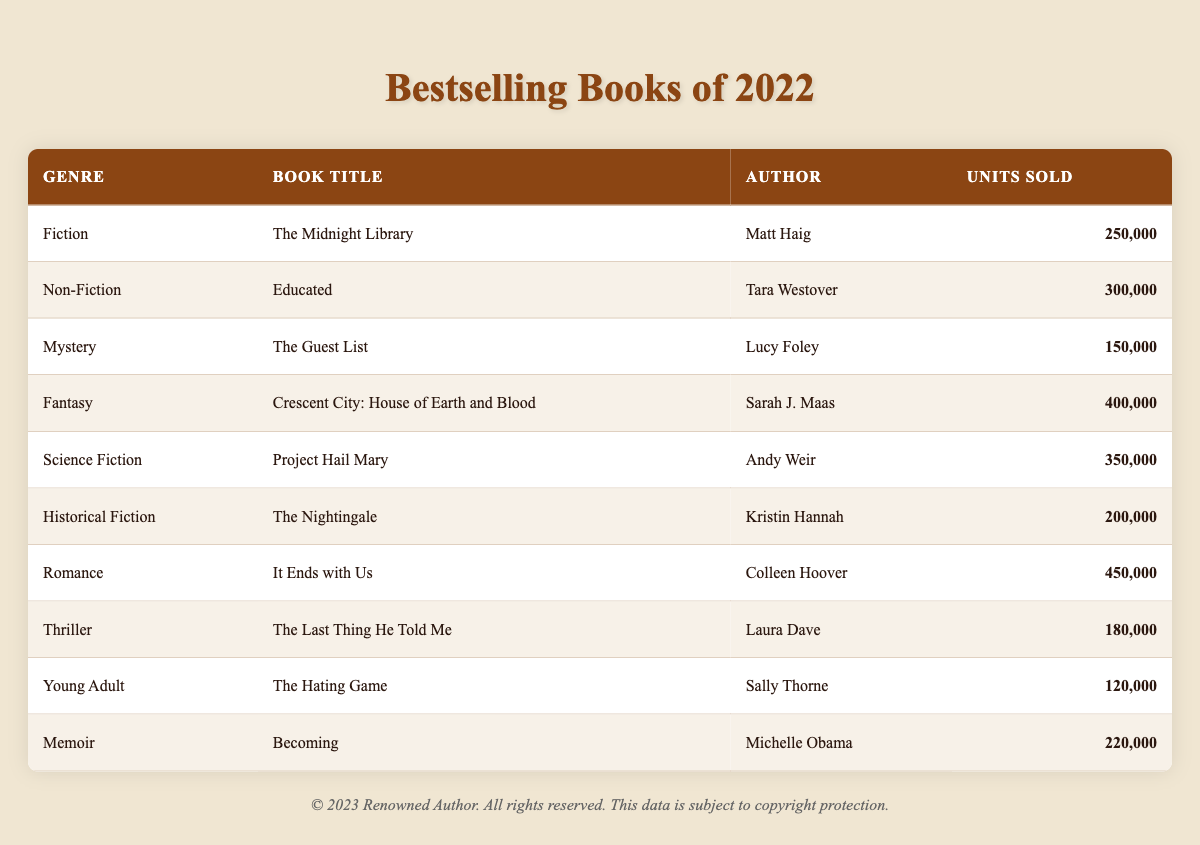What is the genre of "The Midnight Library"? The table lists the book "The Midnight Library" under the genre column, which shows it is categorized as "Fiction."
Answer: Fiction Which book sold the most units in 2022? By examining the units sold column, "It Ends with Us" has the highest figure at 450,000 units.
Answer: It Ends with Us How many units were sold in total across all genres? To find the total, sum the units sold for all books: (250,000 + 300,000 + 150,000 + 400,000 + 350,000 + 200,000 + 450,000 + 180,000 + 120,000 + 220,000) = 2,620,000.
Answer: 2,620,000 What is the average number of units sold per genre? There are 10 genres listed; total units sold is 2,620,000. To find the average: 2,620,000 / 10 = 262,000.
Answer: 262,000 Is "Crescent City: House of Earth and Blood" the highest-selling Fantasy book? It is the only Fantasy book listed with 400,000 units sold, making it the highest-selling in that genre.
Answer: Yes How many genres sold more than 250,000 units? The following genres sold more than 250,000 units: Romance (450,000), Fantasy (400,000), Science Fiction (350,000), Non-Fiction (300,000). This counts as 4 genres.
Answer: 4 What is the difference in units sold between the highest and lowest selling book? The highest selling book "It Ends with Us" sold 450,000 units, while the lowest "The Hating Game" sold 120,000 units. The difference is 450,000 - 120,000 = 330,000.
Answer: 330,000 Did any Memoir book sell fewer units than any of the Historical Fiction books? "Becoming" sold 220,000 units while "The Nightingale" sold 200,000 units. Therefore, no memoir sold fewer units than Historical Fiction.
Answer: No Which genre had the lowest sales in 2022? By comparing the units sold, "Young Adult" with 120,000 units is the lowest selling genre in 2022.
Answer: Young Adult What are the total units sold for non-fiction and memoir combined? Add the units sold for "Educated" (300,000) and "Becoming" (220,000): 300,000 + 220,000 = 520,000.
Answer: 520,000 